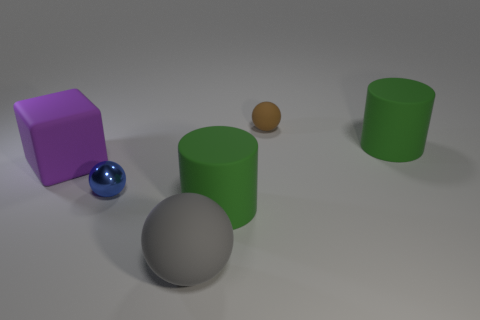Are there more large gray matte things than green cylinders?
Your response must be concise. No. There is a large cylinder that is on the left side of the brown rubber ball; what color is it?
Ensure brevity in your answer.  Green. What size is the thing that is in front of the brown rubber thing and behind the big purple rubber cube?
Offer a terse response. Large. How many blue shiny balls are the same size as the gray object?
Your answer should be compact. 0. What is the material of the blue object that is the same shape as the brown object?
Ensure brevity in your answer.  Metal. Is the shape of the tiny matte object the same as the large purple thing?
Give a very brief answer. No. What number of large purple blocks are in front of the large ball?
Offer a very short reply. 0. What shape is the rubber thing on the right side of the matte ball that is right of the large gray thing?
Ensure brevity in your answer.  Cylinder. The large gray object that is made of the same material as the cube is what shape?
Ensure brevity in your answer.  Sphere. Is the size of the ball that is to the right of the large matte ball the same as the ball left of the gray thing?
Offer a terse response. Yes. 